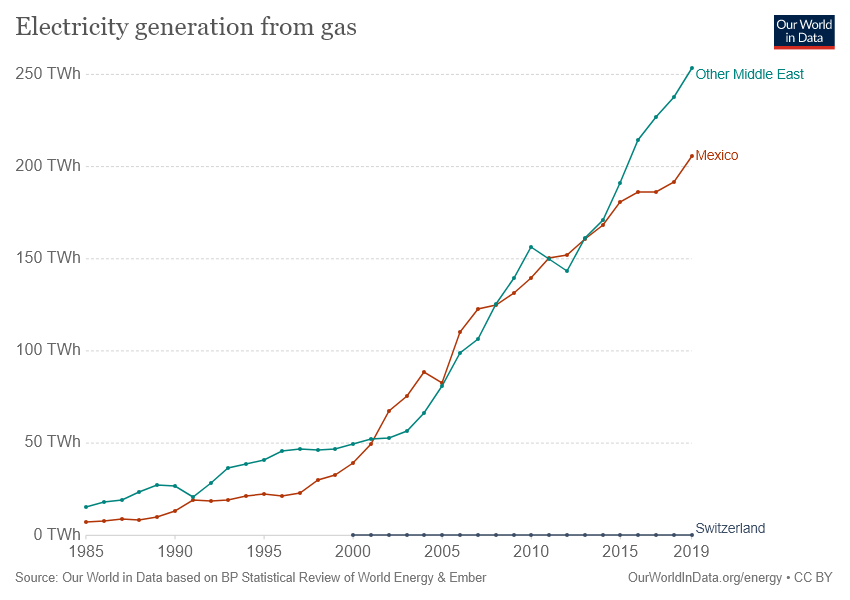List a handful of essential elements in this visual. In 2019, the highest level of electricity generation from gas was recorded in Mexico. In recent years, electricity generation in Mexico has exceeded 150 TWh. 